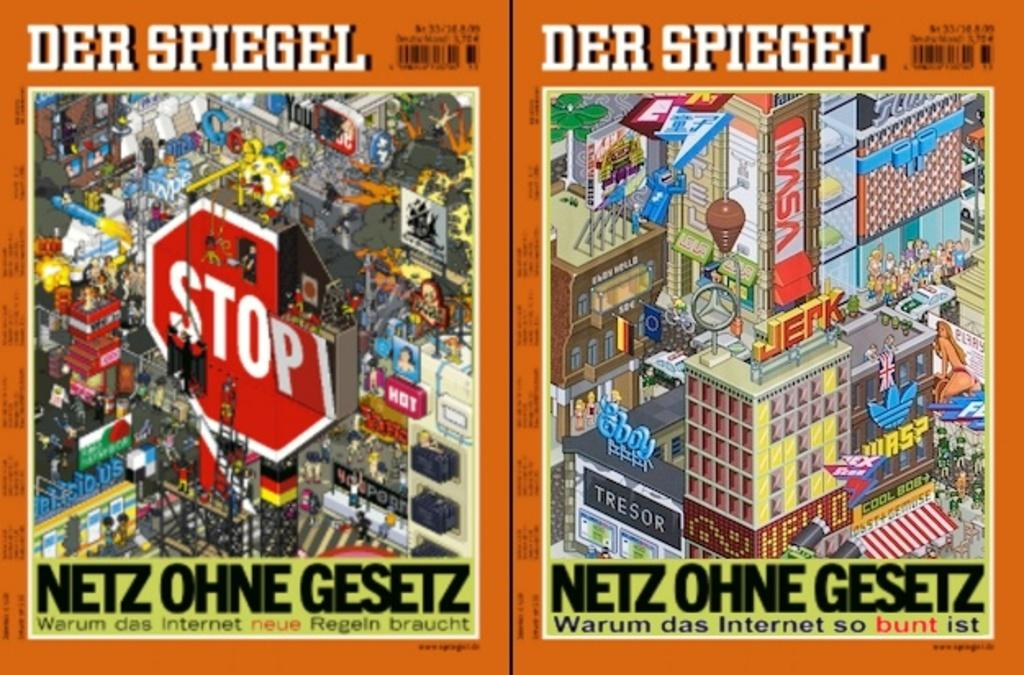<image>
Create a compact narrative representing the image presented. A book called Der Spiegel has colorful illustrations on the cover. 